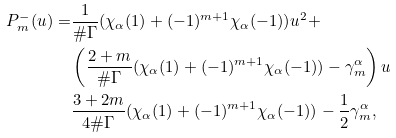<formula> <loc_0><loc_0><loc_500><loc_500>P _ { m } ^ { - } ( u ) = & \frac { 1 } { \# \Gamma } ( \chi _ { \alpha } ( 1 ) + ( - 1 ) ^ { m + 1 } \chi _ { \alpha } ( - 1 ) ) u ^ { 2 } + \\ & \left ( \frac { 2 + m } { \# \Gamma } ( \chi _ { \alpha } ( 1 ) + ( - 1 ) ^ { m + 1 } \chi _ { \alpha } ( - 1 ) ) - \gamma ^ { \alpha } _ { m } \right ) u \\ & \frac { 3 + 2 m } { 4 \# \Gamma } ( \chi _ { \alpha } ( 1 ) + ( - 1 ) ^ { m + 1 } \chi _ { \alpha } ( - 1 ) ) - \frac { 1 } { 2 } \gamma ^ { \alpha } _ { m } ,</formula> 